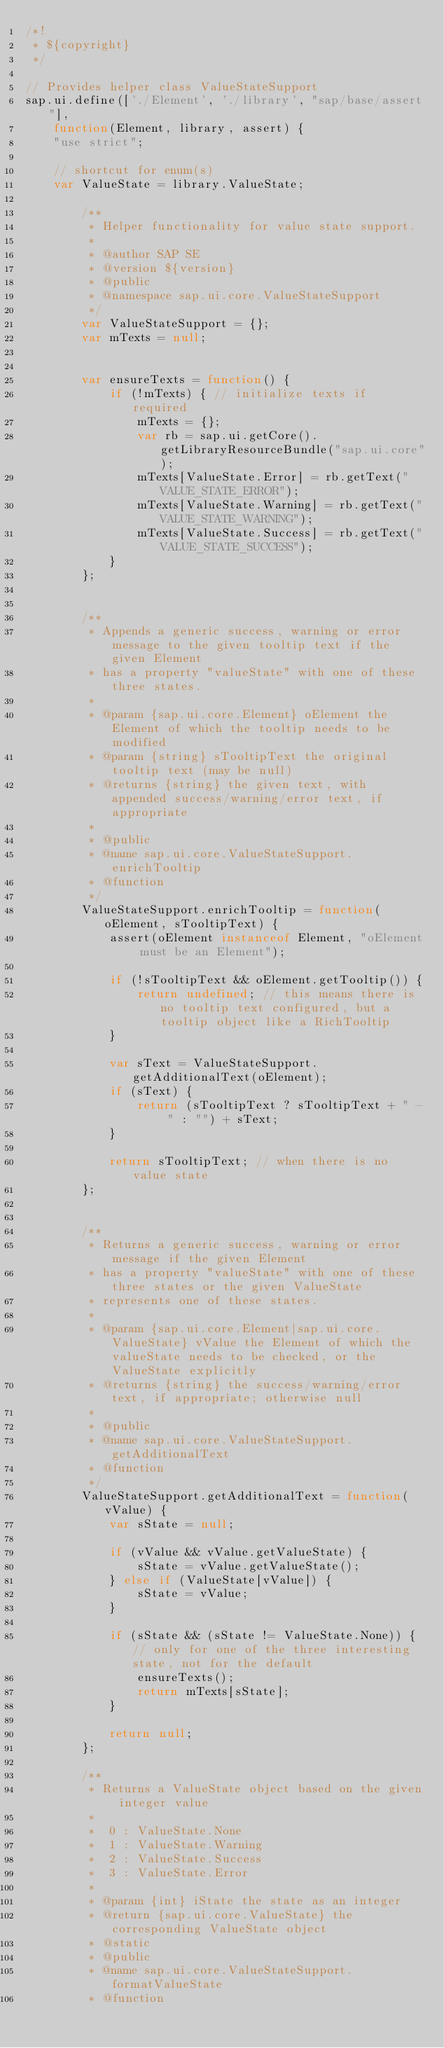<code> <loc_0><loc_0><loc_500><loc_500><_JavaScript_>/*!
 * ${copyright}
 */

// Provides helper class ValueStateSupport
sap.ui.define(['./Element', './library', "sap/base/assert"],
	function(Element, library, assert) {
	"use strict";

	// shortcut for enum(s)
	var ValueState = library.ValueState;

		/**
		 * Helper functionality for value state support.
		 *
		 * @author SAP SE
		 * @version ${version}
		 * @public
		 * @namespace sap.ui.core.ValueStateSupport
		 */
		var ValueStateSupport = {};
		var mTexts = null;


		var ensureTexts = function() {
			if (!mTexts) { // initialize texts if required
				mTexts = {};
				var rb = sap.ui.getCore().getLibraryResourceBundle("sap.ui.core");
				mTexts[ValueState.Error] = rb.getText("VALUE_STATE_ERROR");
				mTexts[ValueState.Warning] = rb.getText("VALUE_STATE_WARNING");
				mTexts[ValueState.Success] = rb.getText("VALUE_STATE_SUCCESS");
			}
		};


		/**
		 * Appends a generic success, warning or error message to the given tooltip text if the given Element
		 * has a property "valueState" with one of these three states.
		 *
		 * @param {sap.ui.core.Element} oElement the Element of which the tooltip needs to be modified
		 * @param {string} sTooltipText the original tooltip text (may be null)
		 * @returns {string} the given text, with appended success/warning/error text, if appropriate
		 *
		 * @public
		 * @name sap.ui.core.ValueStateSupport.enrichTooltip
		 * @function
		 */
		ValueStateSupport.enrichTooltip = function(oElement, sTooltipText) {
			assert(oElement instanceof Element, "oElement must be an Element");

			if (!sTooltipText && oElement.getTooltip()) {
				return undefined; // this means there is no tooltip text configured, but a tooltip object like a RichTooltip
			}

			var sText = ValueStateSupport.getAdditionalText(oElement);
			if (sText) {
				return (sTooltipText ? sTooltipText + " - " : "") + sText;
			}

			return sTooltipText; // when there is no value state
		};


		/**
		 * Returns a generic success, warning or error message if the given Element
		 * has a property "valueState" with one of these three states or the given ValueState
		 * represents one of these states.
		 *
		 * @param {sap.ui.core.Element|sap.ui.core.ValueState} vValue the Element of which the valueState needs to be checked, or the ValueState explicitly
		 * @returns {string} the success/warning/error text, if appropriate; otherwise null
		 *
		 * @public
		 * @name sap.ui.core.ValueStateSupport.getAdditionalText
		 * @function
		 */
		ValueStateSupport.getAdditionalText = function(vValue) {
			var sState = null;

			if (vValue && vValue.getValueState) {
				sState = vValue.getValueState();
			} else if (ValueState[vValue]) {
				sState = vValue;
			}

			if (sState && (sState != ValueState.None)) { // only for one of the three interesting state, not for the default
				ensureTexts();
				return mTexts[sState];
			}

			return null;
		};

		/**
		 * Returns a ValueState object based on the given integer value
		 *
		 *  0 : ValueState.None
		 *  1 : ValueState.Warning
		 *  2 : ValueState.Success
		 *  3 : ValueState.Error
		 *
		 * @param {int} iState the state as an integer
		 * @return {sap.ui.core.ValueState} the corresponding ValueState object
		 * @static
		 * @public
		 * @name sap.ui.core.ValueStateSupport.formatValueState
		 * @function</code> 